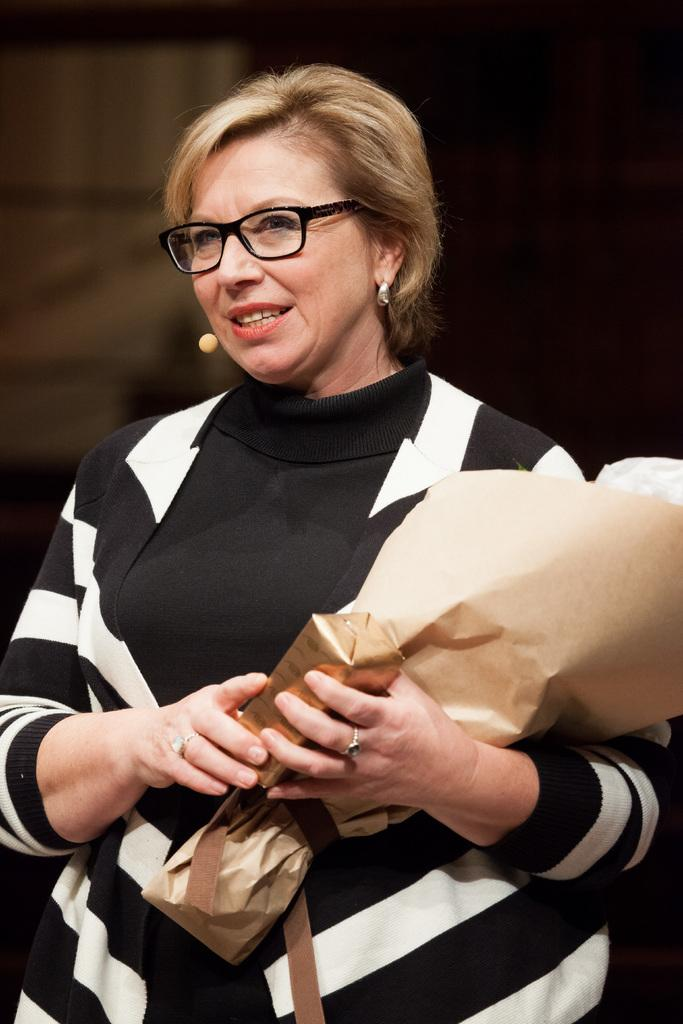Who is the main subject in the picture? There is a woman in the picture. What is the woman doing in the image? The woman is standing. What is the woman holding in the image? The woman is holding a flower bouquet. Can you describe the background of the image? The background of the image is blurred. What type of feast is being prepared in the background of the image? There is no feast present in the image; the background is blurred and does not show any preparation or activity. 